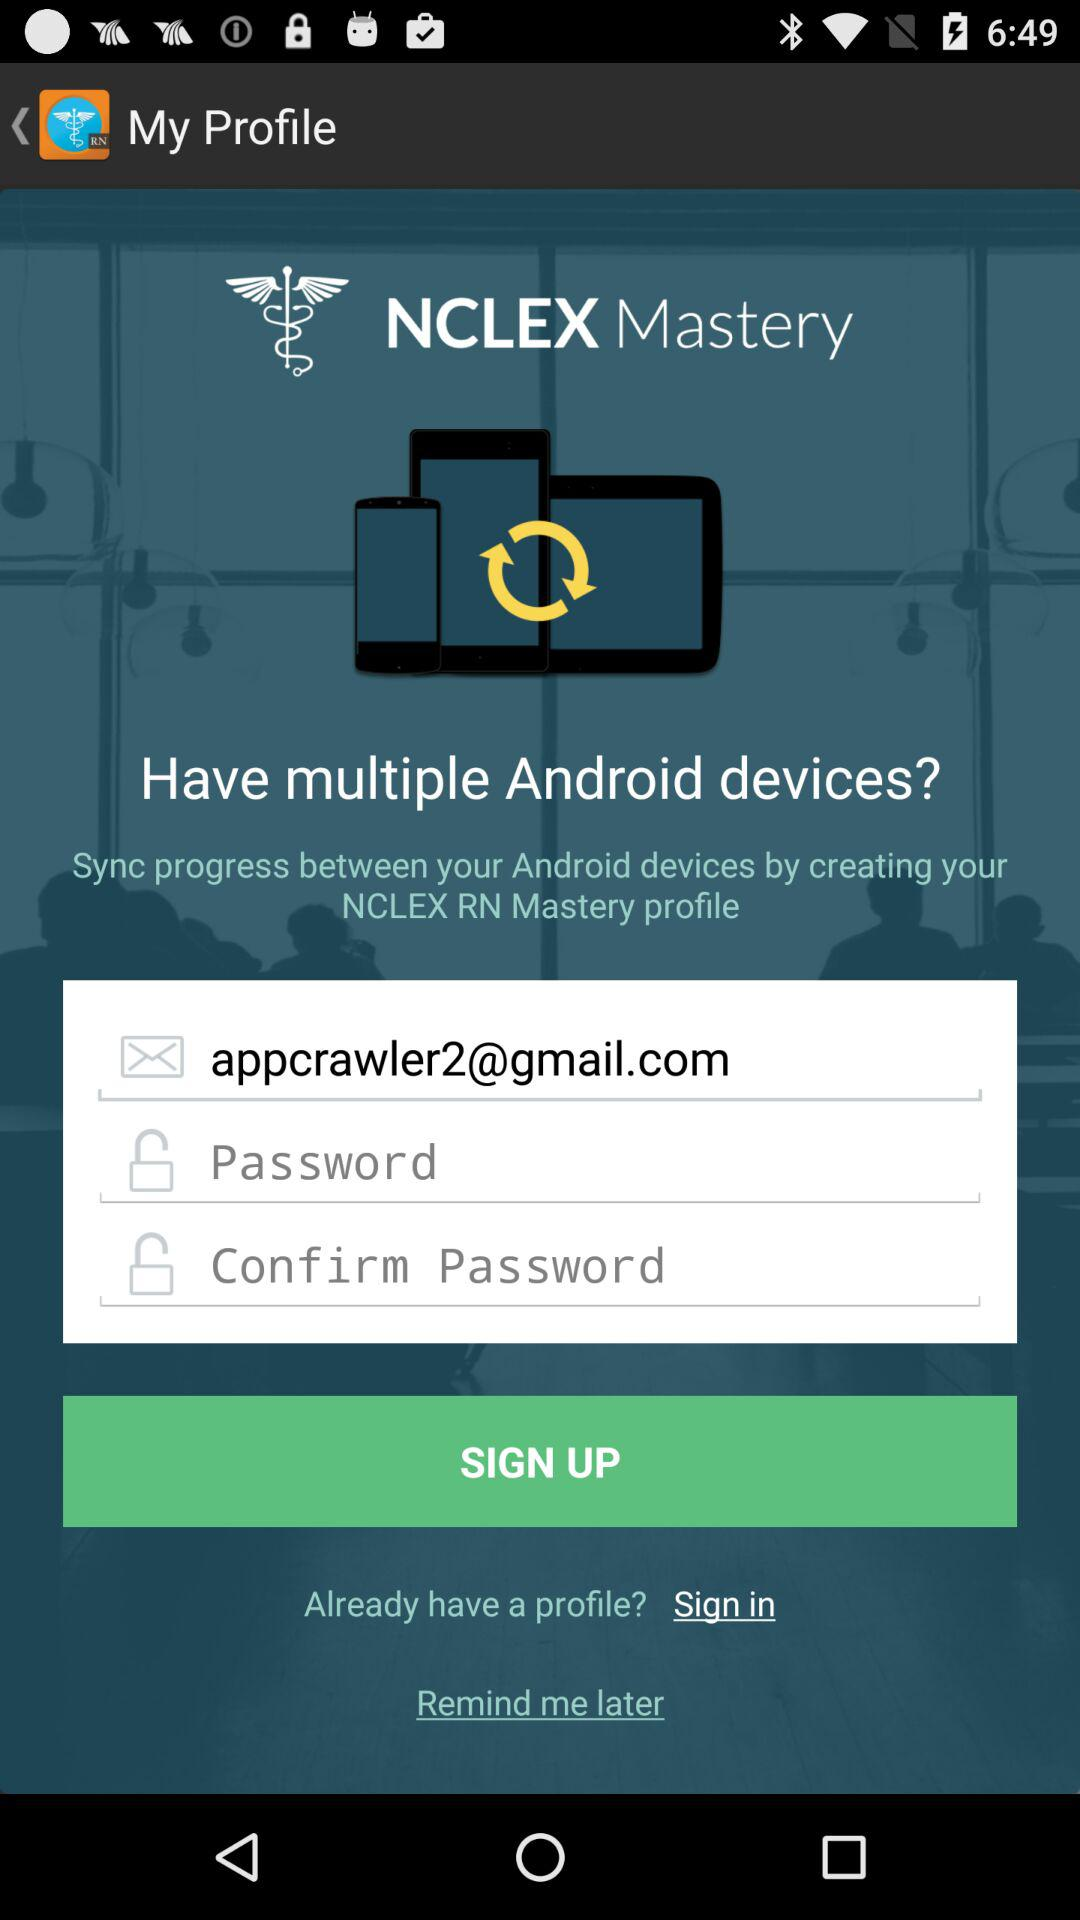How can we sync progress between our Android devices? You can sync your progress between your Android device by creating your NCLEX RN Mastery profile. 